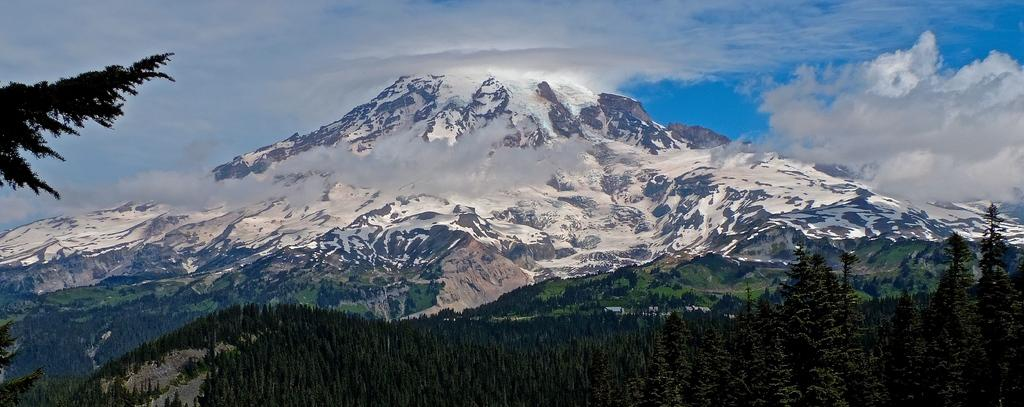What type of natural formation can be seen in the image? There are mountains in the image. What type of vegetation is present at the bottom of the image? There are trees at the bottom of the image. What is visible at the top of the image? The sky is visible at the top of the image. What word is written on the side of the mountain in the image? There are no words visible on the mountains in the image. How many chickens can be seen in the image? There are no chickens present in the image. 